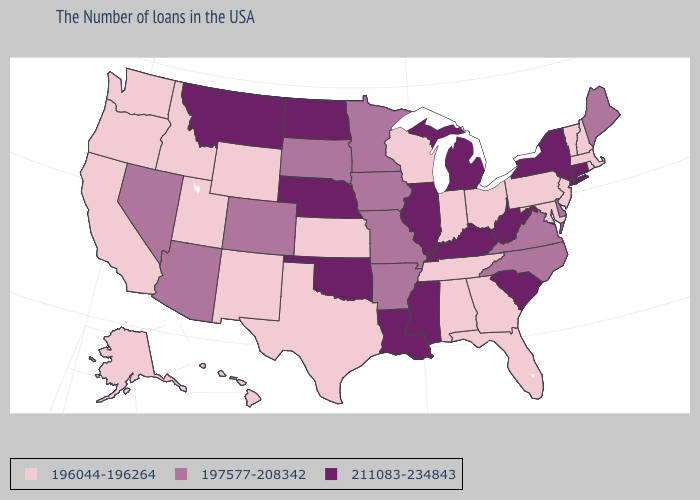Does Montana have the lowest value in the USA?
Answer briefly. No. Does California have a lower value than Montana?
Answer briefly. Yes. What is the value of Maine?
Keep it brief. 197577-208342. Does Louisiana have the highest value in the USA?
Answer briefly. Yes. Does New York have the highest value in the Northeast?
Give a very brief answer. Yes. What is the value of Pennsylvania?
Concise answer only. 196044-196264. What is the lowest value in states that border Ohio?
Answer briefly. 196044-196264. Among the states that border Nebraska , does Kansas have the lowest value?
Write a very short answer. Yes. Does the first symbol in the legend represent the smallest category?
Concise answer only. Yes. What is the lowest value in the MidWest?
Concise answer only. 196044-196264. Does Iowa have a lower value than South Carolina?
Short answer required. Yes. Is the legend a continuous bar?
Quick response, please. No. Does Kentucky have the highest value in the USA?
Be succinct. Yes. Among the states that border Arkansas , which have the highest value?
Concise answer only. Mississippi, Louisiana, Oklahoma. Name the states that have a value in the range 196044-196264?
Keep it brief. Massachusetts, Rhode Island, New Hampshire, Vermont, New Jersey, Maryland, Pennsylvania, Ohio, Florida, Georgia, Indiana, Alabama, Tennessee, Wisconsin, Kansas, Texas, Wyoming, New Mexico, Utah, Idaho, California, Washington, Oregon, Alaska, Hawaii. 